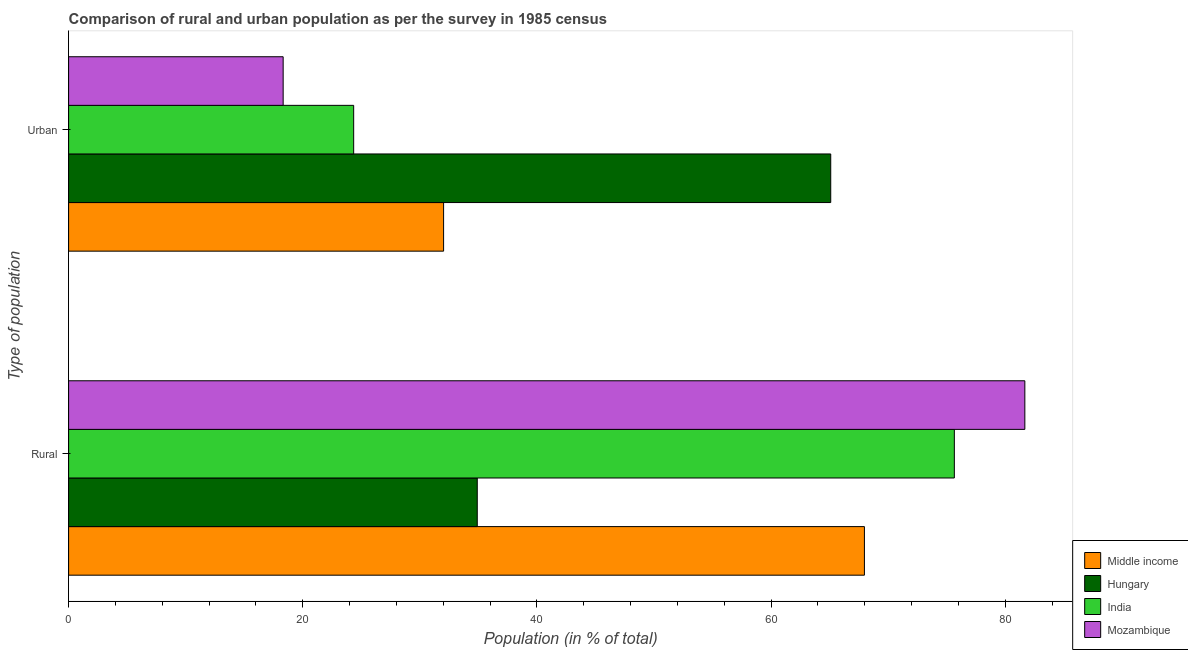How many groups of bars are there?
Provide a succinct answer. 2. Are the number of bars on each tick of the Y-axis equal?
Offer a very short reply. Yes. How many bars are there on the 1st tick from the top?
Provide a short and direct response. 4. What is the label of the 1st group of bars from the top?
Offer a terse response. Urban. What is the urban population in Middle income?
Give a very brief answer. 32.03. Across all countries, what is the maximum urban population?
Offer a terse response. 65.09. Across all countries, what is the minimum urban population?
Provide a succinct answer. 18.33. In which country was the urban population maximum?
Provide a short and direct response. Hungary. In which country was the rural population minimum?
Offer a very short reply. Hungary. What is the total urban population in the graph?
Ensure brevity in your answer.  139.8. What is the difference between the urban population in Middle income and that in Hungary?
Give a very brief answer. -33.07. What is the difference between the rural population in Middle income and the urban population in India?
Offer a terse response. 43.62. What is the average urban population per country?
Your answer should be compact. 34.95. What is the difference between the urban population and rural population in Hungary?
Ensure brevity in your answer.  30.19. In how many countries, is the rural population greater than 4 %?
Your response must be concise. 4. What is the ratio of the rural population in Mozambique to that in India?
Provide a short and direct response. 1.08. Is the urban population in Mozambique less than that in India?
Offer a very short reply. Yes. In how many countries, is the urban population greater than the average urban population taken over all countries?
Give a very brief answer. 1. What does the 3rd bar from the bottom in Urban represents?
Give a very brief answer. India. How many bars are there?
Offer a very short reply. 8. What is the difference between two consecutive major ticks on the X-axis?
Your answer should be very brief. 20. Are the values on the major ticks of X-axis written in scientific E-notation?
Ensure brevity in your answer.  No. Does the graph contain any zero values?
Make the answer very short. No. How many legend labels are there?
Offer a very short reply. 4. How are the legend labels stacked?
Your answer should be compact. Vertical. What is the title of the graph?
Your answer should be compact. Comparison of rural and urban population as per the survey in 1985 census. Does "Luxembourg" appear as one of the legend labels in the graph?
Provide a succinct answer. No. What is the label or title of the X-axis?
Ensure brevity in your answer.  Population (in % of total). What is the label or title of the Y-axis?
Provide a short and direct response. Type of population. What is the Population (in % of total) in Middle income in Rural?
Offer a very short reply. 67.97. What is the Population (in % of total) in Hungary in Rural?
Offer a very short reply. 34.91. What is the Population (in % of total) in India in Rural?
Your answer should be compact. 75.65. What is the Population (in % of total) in Mozambique in Rural?
Your answer should be compact. 81.67. What is the Population (in % of total) in Middle income in Urban?
Provide a short and direct response. 32.03. What is the Population (in % of total) of Hungary in Urban?
Your answer should be very brief. 65.09. What is the Population (in % of total) of India in Urban?
Provide a short and direct response. 24.35. What is the Population (in % of total) of Mozambique in Urban?
Keep it short and to the point. 18.33. Across all Type of population, what is the maximum Population (in % of total) of Middle income?
Keep it short and to the point. 67.97. Across all Type of population, what is the maximum Population (in % of total) in Hungary?
Your answer should be compact. 65.09. Across all Type of population, what is the maximum Population (in % of total) of India?
Your response must be concise. 75.65. Across all Type of population, what is the maximum Population (in % of total) in Mozambique?
Keep it short and to the point. 81.67. Across all Type of population, what is the minimum Population (in % of total) in Middle income?
Provide a succinct answer. 32.03. Across all Type of population, what is the minimum Population (in % of total) in Hungary?
Make the answer very short. 34.91. Across all Type of population, what is the minimum Population (in % of total) of India?
Give a very brief answer. 24.35. Across all Type of population, what is the minimum Population (in % of total) of Mozambique?
Ensure brevity in your answer.  18.33. What is the total Population (in % of total) in Mozambique in the graph?
Your answer should be very brief. 100. What is the difference between the Population (in % of total) in Middle income in Rural and that in Urban?
Your response must be concise. 35.94. What is the difference between the Population (in % of total) of Hungary in Rural and that in Urban?
Offer a terse response. -30.19. What is the difference between the Population (in % of total) of India in Rural and that in Urban?
Make the answer very short. 51.3. What is the difference between the Population (in % of total) of Mozambique in Rural and that in Urban?
Your answer should be very brief. 63.35. What is the difference between the Population (in % of total) in Middle income in Rural and the Population (in % of total) in Hungary in Urban?
Keep it short and to the point. 2.88. What is the difference between the Population (in % of total) in Middle income in Rural and the Population (in % of total) in India in Urban?
Your response must be concise. 43.62. What is the difference between the Population (in % of total) in Middle income in Rural and the Population (in % of total) in Mozambique in Urban?
Offer a terse response. 49.65. What is the difference between the Population (in % of total) of Hungary in Rural and the Population (in % of total) of India in Urban?
Your response must be concise. 10.56. What is the difference between the Population (in % of total) in Hungary in Rural and the Population (in % of total) in Mozambique in Urban?
Your answer should be compact. 16.58. What is the difference between the Population (in % of total) of India in Rural and the Population (in % of total) of Mozambique in Urban?
Offer a very short reply. 57.33. What is the average Population (in % of total) in Middle income per Type of population?
Ensure brevity in your answer.  50. What is the average Population (in % of total) in India per Type of population?
Provide a short and direct response. 50. What is the difference between the Population (in % of total) in Middle income and Population (in % of total) in Hungary in Rural?
Keep it short and to the point. 33.07. What is the difference between the Population (in % of total) of Middle income and Population (in % of total) of India in Rural?
Provide a short and direct response. -7.68. What is the difference between the Population (in % of total) in Middle income and Population (in % of total) in Mozambique in Rural?
Give a very brief answer. -13.7. What is the difference between the Population (in % of total) in Hungary and Population (in % of total) in India in Rural?
Offer a very short reply. -40.75. What is the difference between the Population (in % of total) of Hungary and Population (in % of total) of Mozambique in Rural?
Your response must be concise. -46.77. What is the difference between the Population (in % of total) of India and Population (in % of total) of Mozambique in Rural?
Your answer should be compact. -6.02. What is the difference between the Population (in % of total) of Middle income and Population (in % of total) of Hungary in Urban?
Your response must be concise. -33.07. What is the difference between the Population (in % of total) of Middle income and Population (in % of total) of India in Urban?
Provide a succinct answer. 7.68. What is the difference between the Population (in % of total) of Middle income and Population (in % of total) of Mozambique in Urban?
Your response must be concise. 13.7. What is the difference between the Population (in % of total) of Hungary and Population (in % of total) of India in Urban?
Give a very brief answer. 40.75. What is the difference between the Population (in % of total) in Hungary and Population (in % of total) in Mozambique in Urban?
Offer a very short reply. 46.77. What is the difference between the Population (in % of total) of India and Population (in % of total) of Mozambique in Urban?
Offer a very short reply. 6.02. What is the ratio of the Population (in % of total) in Middle income in Rural to that in Urban?
Give a very brief answer. 2.12. What is the ratio of the Population (in % of total) of Hungary in Rural to that in Urban?
Make the answer very short. 0.54. What is the ratio of the Population (in % of total) in India in Rural to that in Urban?
Ensure brevity in your answer.  3.11. What is the ratio of the Population (in % of total) in Mozambique in Rural to that in Urban?
Your answer should be compact. 4.46. What is the difference between the highest and the second highest Population (in % of total) in Middle income?
Your answer should be compact. 35.94. What is the difference between the highest and the second highest Population (in % of total) in Hungary?
Provide a succinct answer. 30.19. What is the difference between the highest and the second highest Population (in % of total) of India?
Your answer should be compact. 51.3. What is the difference between the highest and the second highest Population (in % of total) in Mozambique?
Give a very brief answer. 63.35. What is the difference between the highest and the lowest Population (in % of total) in Middle income?
Offer a terse response. 35.94. What is the difference between the highest and the lowest Population (in % of total) in Hungary?
Keep it short and to the point. 30.19. What is the difference between the highest and the lowest Population (in % of total) of India?
Make the answer very short. 51.3. What is the difference between the highest and the lowest Population (in % of total) of Mozambique?
Your response must be concise. 63.35. 